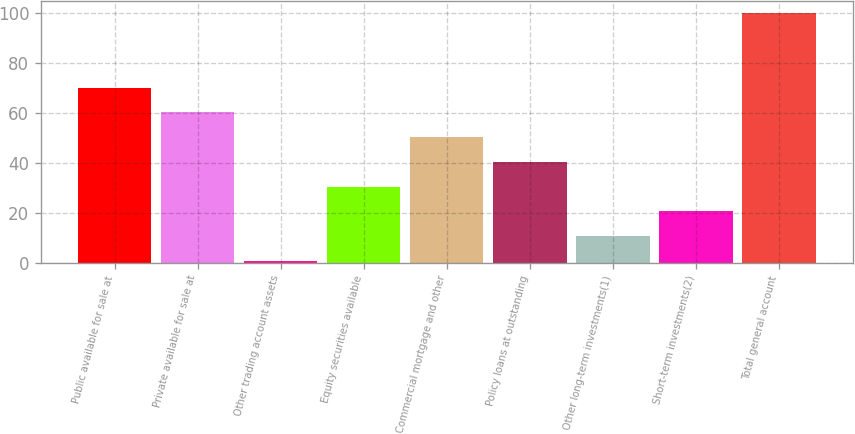Convert chart to OTSL. <chart><loc_0><loc_0><loc_500><loc_500><bar_chart><fcel>Public available for sale at<fcel>Private available for sale at<fcel>Other trading account assets<fcel>Equity securities available<fcel>Commercial mortgage and other<fcel>Policy loans at outstanding<fcel>Other long-term investments(1)<fcel>Short-term investments(2)<fcel>Total general account<nl><fcel>70.21<fcel>60.28<fcel>0.7<fcel>30.49<fcel>50.35<fcel>40.42<fcel>10.63<fcel>20.56<fcel>100<nl></chart> 